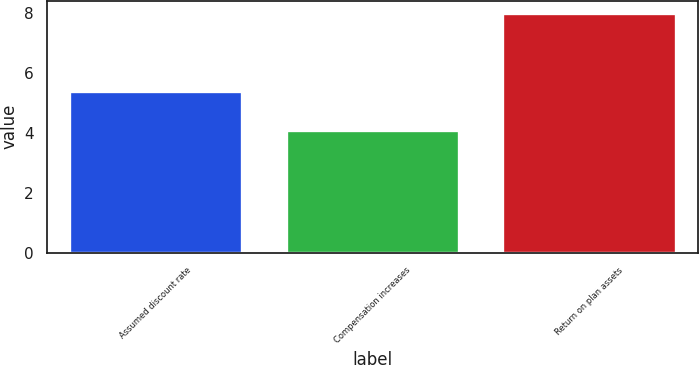Convert chart to OTSL. <chart><loc_0><loc_0><loc_500><loc_500><bar_chart><fcel>Assumed discount rate<fcel>Compensation increases<fcel>Return on plan assets<nl><fcel>5.4<fcel>4.1<fcel>8<nl></chart> 